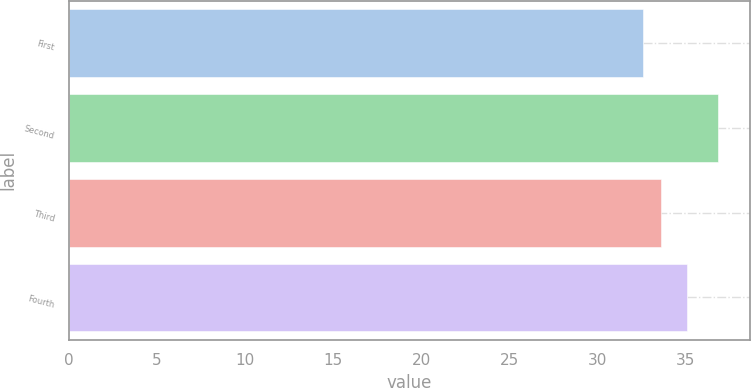Convert chart. <chart><loc_0><loc_0><loc_500><loc_500><bar_chart><fcel>First<fcel>Second<fcel>Third<fcel>Fourth<nl><fcel>32.56<fcel>36.82<fcel>33.6<fcel>35.1<nl></chart> 